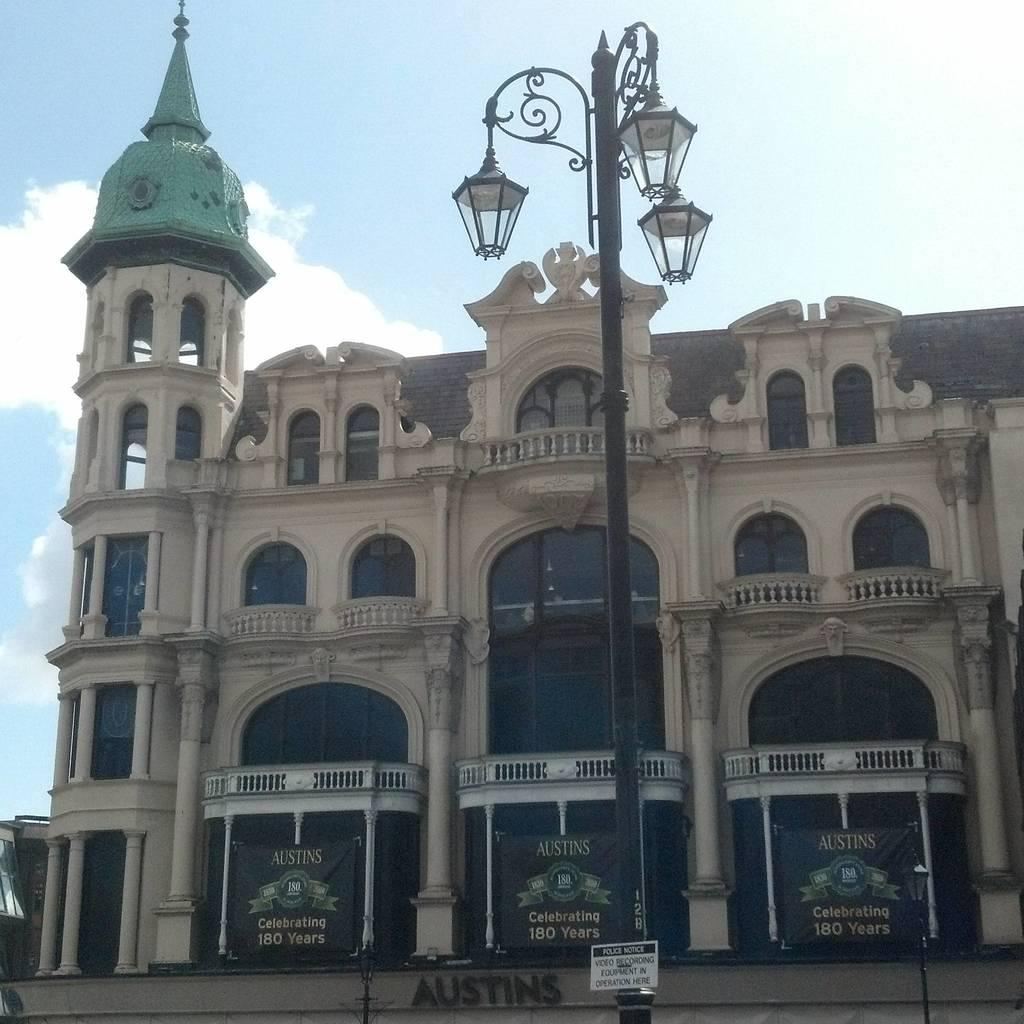Provide a one-sentence caption for the provided image. An old stone building with the word "Austins" on the front. 